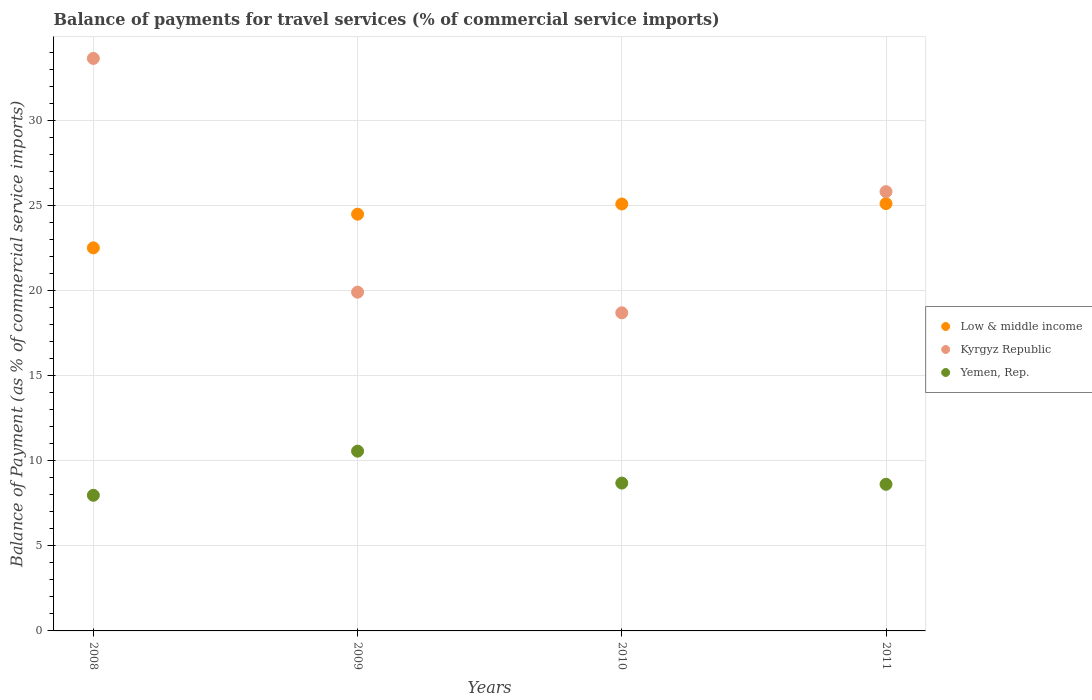What is the balance of payments for travel services in Low & middle income in 2009?
Your answer should be compact. 24.5. Across all years, what is the maximum balance of payments for travel services in Kyrgyz Republic?
Your answer should be very brief. 33.66. Across all years, what is the minimum balance of payments for travel services in Kyrgyz Republic?
Provide a short and direct response. 18.7. What is the total balance of payments for travel services in Low & middle income in the graph?
Your response must be concise. 97.25. What is the difference between the balance of payments for travel services in Kyrgyz Republic in 2008 and that in 2009?
Ensure brevity in your answer.  13.74. What is the difference between the balance of payments for travel services in Kyrgyz Republic in 2011 and the balance of payments for travel services in Yemen, Rep. in 2010?
Give a very brief answer. 17.14. What is the average balance of payments for travel services in Low & middle income per year?
Offer a terse response. 24.31. In the year 2011, what is the difference between the balance of payments for travel services in Low & middle income and balance of payments for travel services in Yemen, Rep.?
Make the answer very short. 16.5. In how many years, is the balance of payments for travel services in Yemen, Rep. greater than 15 %?
Give a very brief answer. 0. What is the ratio of the balance of payments for travel services in Kyrgyz Republic in 2009 to that in 2011?
Keep it short and to the point. 0.77. What is the difference between the highest and the second highest balance of payments for travel services in Low & middle income?
Give a very brief answer. 0.02. What is the difference between the highest and the lowest balance of payments for travel services in Yemen, Rep.?
Your response must be concise. 2.6. Is the balance of payments for travel services in Yemen, Rep. strictly greater than the balance of payments for travel services in Kyrgyz Republic over the years?
Your response must be concise. No. Is the balance of payments for travel services in Kyrgyz Republic strictly less than the balance of payments for travel services in Yemen, Rep. over the years?
Make the answer very short. No. What is the difference between two consecutive major ticks on the Y-axis?
Ensure brevity in your answer.  5. Are the values on the major ticks of Y-axis written in scientific E-notation?
Your answer should be very brief. No. Does the graph contain any zero values?
Your answer should be very brief. No. Does the graph contain grids?
Make the answer very short. Yes. Where does the legend appear in the graph?
Offer a very short reply. Center right. How many legend labels are there?
Offer a terse response. 3. How are the legend labels stacked?
Ensure brevity in your answer.  Vertical. What is the title of the graph?
Give a very brief answer. Balance of payments for travel services (% of commercial service imports). What is the label or title of the Y-axis?
Provide a succinct answer. Balance of Payment (as % of commercial service imports). What is the Balance of Payment (as % of commercial service imports) of Low & middle income in 2008?
Your response must be concise. 22.52. What is the Balance of Payment (as % of commercial service imports) of Kyrgyz Republic in 2008?
Provide a short and direct response. 33.66. What is the Balance of Payment (as % of commercial service imports) of Yemen, Rep. in 2008?
Make the answer very short. 7.97. What is the Balance of Payment (as % of commercial service imports) in Low & middle income in 2009?
Offer a terse response. 24.5. What is the Balance of Payment (as % of commercial service imports) in Kyrgyz Republic in 2009?
Your answer should be very brief. 19.92. What is the Balance of Payment (as % of commercial service imports) in Yemen, Rep. in 2009?
Make the answer very short. 10.57. What is the Balance of Payment (as % of commercial service imports) in Low & middle income in 2010?
Your answer should be very brief. 25.1. What is the Balance of Payment (as % of commercial service imports) in Kyrgyz Republic in 2010?
Offer a very short reply. 18.7. What is the Balance of Payment (as % of commercial service imports) in Yemen, Rep. in 2010?
Your answer should be very brief. 8.69. What is the Balance of Payment (as % of commercial service imports) of Low & middle income in 2011?
Provide a succinct answer. 25.12. What is the Balance of Payment (as % of commercial service imports) in Kyrgyz Republic in 2011?
Offer a terse response. 25.83. What is the Balance of Payment (as % of commercial service imports) of Yemen, Rep. in 2011?
Your response must be concise. 8.62. Across all years, what is the maximum Balance of Payment (as % of commercial service imports) in Low & middle income?
Provide a succinct answer. 25.12. Across all years, what is the maximum Balance of Payment (as % of commercial service imports) in Kyrgyz Republic?
Provide a short and direct response. 33.66. Across all years, what is the maximum Balance of Payment (as % of commercial service imports) of Yemen, Rep.?
Provide a short and direct response. 10.57. Across all years, what is the minimum Balance of Payment (as % of commercial service imports) in Low & middle income?
Your response must be concise. 22.52. Across all years, what is the minimum Balance of Payment (as % of commercial service imports) of Kyrgyz Republic?
Your answer should be very brief. 18.7. Across all years, what is the minimum Balance of Payment (as % of commercial service imports) of Yemen, Rep.?
Offer a very short reply. 7.97. What is the total Balance of Payment (as % of commercial service imports) in Low & middle income in the graph?
Give a very brief answer. 97.25. What is the total Balance of Payment (as % of commercial service imports) of Kyrgyz Republic in the graph?
Your answer should be very brief. 98.11. What is the total Balance of Payment (as % of commercial service imports) of Yemen, Rep. in the graph?
Keep it short and to the point. 35.86. What is the difference between the Balance of Payment (as % of commercial service imports) in Low & middle income in 2008 and that in 2009?
Ensure brevity in your answer.  -1.98. What is the difference between the Balance of Payment (as % of commercial service imports) in Kyrgyz Republic in 2008 and that in 2009?
Offer a very short reply. 13.74. What is the difference between the Balance of Payment (as % of commercial service imports) in Yemen, Rep. in 2008 and that in 2009?
Provide a succinct answer. -2.6. What is the difference between the Balance of Payment (as % of commercial service imports) in Low & middle income in 2008 and that in 2010?
Your answer should be very brief. -2.58. What is the difference between the Balance of Payment (as % of commercial service imports) in Kyrgyz Republic in 2008 and that in 2010?
Provide a succinct answer. 14.96. What is the difference between the Balance of Payment (as % of commercial service imports) of Yemen, Rep. in 2008 and that in 2010?
Give a very brief answer. -0.72. What is the difference between the Balance of Payment (as % of commercial service imports) in Low & middle income in 2008 and that in 2011?
Keep it short and to the point. -2.6. What is the difference between the Balance of Payment (as % of commercial service imports) of Kyrgyz Republic in 2008 and that in 2011?
Give a very brief answer. 7.83. What is the difference between the Balance of Payment (as % of commercial service imports) in Yemen, Rep. in 2008 and that in 2011?
Your answer should be compact. -0.65. What is the difference between the Balance of Payment (as % of commercial service imports) in Low & middle income in 2009 and that in 2010?
Give a very brief answer. -0.6. What is the difference between the Balance of Payment (as % of commercial service imports) in Kyrgyz Republic in 2009 and that in 2010?
Give a very brief answer. 1.21. What is the difference between the Balance of Payment (as % of commercial service imports) of Yemen, Rep. in 2009 and that in 2010?
Ensure brevity in your answer.  1.88. What is the difference between the Balance of Payment (as % of commercial service imports) in Low & middle income in 2009 and that in 2011?
Your answer should be very brief. -0.62. What is the difference between the Balance of Payment (as % of commercial service imports) of Kyrgyz Republic in 2009 and that in 2011?
Offer a very short reply. -5.91. What is the difference between the Balance of Payment (as % of commercial service imports) of Yemen, Rep. in 2009 and that in 2011?
Provide a short and direct response. 1.95. What is the difference between the Balance of Payment (as % of commercial service imports) of Low & middle income in 2010 and that in 2011?
Provide a short and direct response. -0.02. What is the difference between the Balance of Payment (as % of commercial service imports) of Kyrgyz Republic in 2010 and that in 2011?
Provide a short and direct response. -7.12. What is the difference between the Balance of Payment (as % of commercial service imports) of Yemen, Rep. in 2010 and that in 2011?
Make the answer very short. 0.07. What is the difference between the Balance of Payment (as % of commercial service imports) in Low & middle income in 2008 and the Balance of Payment (as % of commercial service imports) in Kyrgyz Republic in 2009?
Your answer should be very brief. 2.61. What is the difference between the Balance of Payment (as % of commercial service imports) in Low & middle income in 2008 and the Balance of Payment (as % of commercial service imports) in Yemen, Rep. in 2009?
Ensure brevity in your answer.  11.95. What is the difference between the Balance of Payment (as % of commercial service imports) in Kyrgyz Republic in 2008 and the Balance of Payment (as % of commercial service imports) in Yemen, Rep. in 2009?
Your answer should be very brief. 23.09. What is the difference between the Balance of Payment (as % of commercial service imports) of Low & middle income in 2008 and the Balance of Payment (as % of commercial service imports) of Kyrgyz Republic in 2010?
Your answer should be very brief. 3.82. What is the difference between the Balance of Payment (as % of commercial service imports) in Low & middle income in 2008 and the Balance of Payment (as % of commercial service imports) in Yemen, Rep. in 2010?
Give a very brief answer. 13.83. What is the difference between the Balance of Payment (as % of commercial service imports) of Kyrgyz Republic in 2008 and the Balance of Payment (as % of commercial service imports) of Yemen, Rep. in 2010?
Offer a very short reply. 24.97. What is the difference between the Balance of Payment (as % of commercial service imports) of Low & middle income in 2008 and the Balance of Payment (as % of commercial service imports) of Kyrgyz Republic in 2011?
Give a very brief answer. -3.3. What is the difference between the Balance of Payment (as % of commercial service imports) in Low & middle income in 2008 and the Balance of Payment (as % of commercial service imports) in Yemen, Rep. in 2011?
Provide a short and direct response. 13.9. What is the difference between the Balance of Payment (as % of commercial service imports) in Kyrgyz Republic in 2008 and the Balance of Payment (as % of commercial service imports) in Yemen, Rep. in 2011?
Your answer should be compact. 25.04. What is the difference between the Balance of Payment (as % of commercial service imports) of Low & middle income in 2009 and the Balance of Payment (as % of commercial service imports) of Kyrgyz Republic in 2010?
Give a very brief answer. 5.8. What is the difference between the Balance of Payment (as % of commercial service imports) of Low & middle income in 2009 and the Balance of Payment (as % of commercial service imports) of Yemen, Rep. in 2010?
Offer a terse response. 15.81. What is the difference between the Balance of Payment (as % of commercial service imports) in Kyrgyz Republic in 2009 and the Balance of Payment (as % of commercial service imports) in Yemen, Rep. in 2010?
Your answer should be very brief. 11.23. What is the difference between the Balance of Payment (as % of commercial service imports) in Low & middle income in 2009 and the Balance of Payment (as % of commercial service imports) in Kyrgyz Republic in 2011?
Provide a short and direct response. -1.33. What is the difference between the Balance of Payment (as % of commercial service imports) in Low & middle income in 2009 and the Balance of Payment (as % of commercial service imports) in Yemen, Rep. in 2011?
Give a very brief answer. 15.88. What is the difference between the Balance of Payment (as % of commercial service imports) in Kyrgyz Republic in 2009 and the Balance of Payment (as % of commercial service imports) in Yemen, Rep. in 2011?
Ensure brevity in your answer.  11.3. What is the difference between the Balance of Payment (as % of commercial service imports) in Low & middle income in 2010 and the Balance of Payment (as % of commercial service imports) in Kyrgyz Republic in 2011?
Your answer should be compact. -0.73. What is the difference between the Balance of Payment (as % of commercial service imports) of Low & middle income in 2010 and the Balance of Payment (as % of commercial service imports) of Yemen, Rep. in 2011?
Ensure brevity in your answer.  16.48. What is the difference between the Balance of Payment (as % of commercial service imports) of Kyrgyz Republic in 2010 and the Balance of Payment (as % of commercial service imports) of Yemen, Rep. in 2011?
Your answer should be very brief. 10.08. What is the average Balance of Payment (as % of commercial service imports) in Low & middle income per year?
Keep it short and to the point. 24.31. What is the average Balance of Payment (as % of commercial service imports) in Kyrgyz Republic per year?
Make the answer very short. 24.53. What is the average Balance of Payment (as % of commercial service imports) of Yemen, Rep. per year?
Ensure brevity in your answer.  8.96. In the year 2008, what is the difference between the Balance of Payment (as % of commercial service imports) in Low & middle income and Balance of Payment (as % of commercial service imports) in Kyrgyz Republic?
Provide a short and direct response. -11.14. In the year 2008, what is the difference between the Balance of Payment (as % of commercial service imports) in Low & middle income and Balance of Payment (as % of commercial service imports) in Yemen, Rep.?
Your answer should be compact. 14.55. In the year 2008, what is the difference between the Balance of Payment (as % of commercial service imports) in Kyrgyz Republic and Balance of Payment (as % of commercial service imports) in Yemen, Rep.?
Offer a terse response. 25.69. In the year 2009, what is the difference between the Balance of Payment (as % of commercial service imports) of Low & middle income and Balance of Payment (as % of commercial service imports) of Kyrgyz Republic?
Your answer should be compact. 4.58. In the year 2009, what is the difference between the Balance of Payment (as % of commercial service imports) of Low & middle income and Balance of Payment (as % of commercial service imports) of Yemen, Rep.?
Your answer should be very brief. 13.93. In the year 2009, what is the difference between the Balance of Payment (as % of commercial service imports) in Kyrgyz Republic and Balance of Payment (as % of commercial service imports) in Yemen, Rep.?
Your response must be concise. 9.35. In the year 2010, what is the difference between the Balance of Payment (as % of commercial service imports) in Low & middle income and Balance of Payment (as % of commercial service imports) in Kyrgyz Republic?
Make the answer very short. 6.4. In the year 2010, what is the difference between the Balance of Payment (as % of commercial service imports) of Low & middle income and Balance of Payment (as % of commercial service imports) of Yemen, Rep.?
Provide a short and direct response. 16.41. In the year 2010, what is the difference between the Balance of Payment (as % of commercial service imports) of Kyrgyz Republic and Balance of Payment (as % of commercial service imports) of Yemen, Rep.?
Keep it short and to the point. 10.01. In the year 2011, what is the difference between the Balance of Payment (as % of commercial service imports) in Low & middle income and Balance of Payment (as % of commercial service imports) in Kyrgyz Republic?
Provide a short and direct response. -0.7. In the year 2011, what is the difference between the Balance of Payment (as % of commercial service imports) of Low & middle income and Balance of Payment (as % of commercial service imports) of Yemen, Rep.?
Keep it short and to the point. 16.5. In the year 2011, what is the difference between the Balance of Payment (as % of commercial service imports) in Kyrgyz Republic and Balance of Payment (as % of commercial service imports) in Yemen, Rep.?
Provide a succinct answer. 17.21. What is the ratio of the Balance of Payment (as % of commercial service imports) in Low & middle income in 2008 to that in 2009?
Ensure brevity in your answer.  0.92. What is the ratio of the Balance of Payment (as % of commercial service imports) in Kyrgyz Republic in 2008 to that in 2009?
Keep it short and to the point. 1.69. What is the ratio of the Balance of Payment (as % of commercial service imports) of Yemen, Rep. in 2008 to that in 2009?
Ensure brevity in your answer.  0.75. What is the ratio of the Balance of Payment (as % of commercial service imports) of Low & middle income in 2008 to that in 2010?
Ensure brevity in your answer.  0.9. What is the ratio of the Balance of Payment (as % of commercial service imports) of Kyrgyz Republic in 2008 to that in 2010?
Offer a terse response. 1.8. What is the ratio of the Balance of Payment (as % of commercial service imports) in Yemen, Rep. in 2008 to that in 2010?
Your response must be concise. 0.92. What is the ratio of the Balance of Payment (as % of commercial service imports) of Low & middle income in 2008 to that in 2011?
Offer a very short reply. 0.9. What is the ratio of the Balance of Payment (as % of commercial service imports) in Kyrgyz Republic in 2008 to that in 2011?
Make the answer very short. 1.3. What is the ratio of the Balance of Payment (as % of commercial service imports) of Yemen, Rep. in 2008 to that in 2011?
Your response must be concise. 0.92. What is the ratio of the Balance of Payment (as % of commercial service imports) in Low & middle income in 2009 to that in 2010?
Keep it short and to the point. 0.98. What is the ratio of the Balance of Payment (as % of commercial service imports) in Kyrgyz Republic in 2009 to that in 2010?
Your answer should be very brief. 1.06. What is the ratio of the Balance of Payment (as % of commercial service imports) in Yemen, Rep. in 2009 to that in 2010?
Provide a short and direct response. 1.22. What is the ratio of the Balance of Payment (as % of commercial service imports) in Low & middle income in 2009 to that in 2011?
Offer a terse response. 0.98. What is the ratio of the Balance of Payment (as % of commercial service imports) of Kyrgyz Republic in 2009 to that in 2011?
Offer a very short reply. 0.77. What is the ratio of the Balance of Payment (as % of commercial service imports) in Yemen, Rep. in 2009 to that in 2011?
Offer a terse response. 1.23. What is the ratio of the Balance of Payment (as % of commercial service imports) of Low & middle income in 2010 to that in 2011?
Provide a succinct answer. 1. What is the ratio of the Balance of Payment (as % of commercial service imports) in Kyrgyz Republic in 2010 to that in 2011?
Your answer should be very brief. 0.72. What is the ratio of the Balance of Payment (as % of commercial service imports) in Yemen, Rep. in 2010 to that in 2011?
Offer a very short reply. 1.01. What is the difference between the highest and the second highest Balance of Payment (as % of commercial service imports) in Low & middle income?
Offer a very short reply. 0.02. What is the difference between the highest and the second highest Balance of Payment (as % of commercial service imports) in Kyrgyz Republic?
Provide a short and direct response. 7.83. What is the difference between the highest and the second highest Balance of Payment (as % of commercial service imports) in Yemen, Rep.?
Provide a short and direct response. 1.88. What is the difference between the highest and the lowest Balance of Payment (as % of commercial service imports) of Low & middle income?
Provide a short and direct response. 2.6. What is the difference between the highest and the lowest Balance of Payment (as % of commercial service imports) in Kyrgyz Republic?
Your answer should be very brief. 14.96. What is the difference between the highest and the lowest Balance of Payment (as % of commercial service imports) in Yemen, Rep.?
Offer a very short reply. 2.6. 